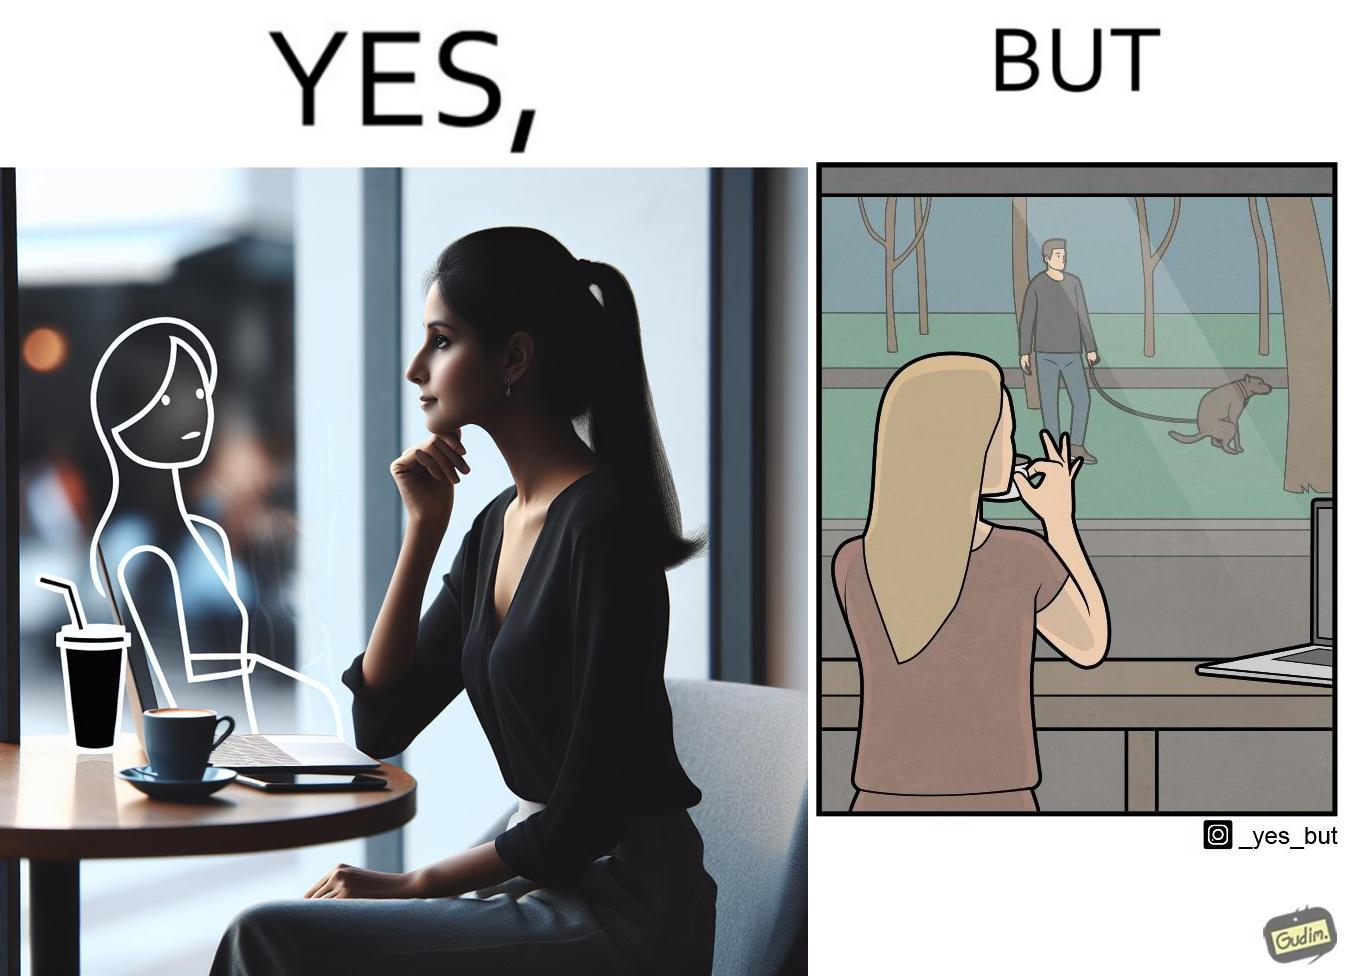What is the satirical meaning behind this image? The image is ironic, because in the first image the woman is seen as enjoying the view but in the second image the same woman is seen as looking at a pooping dog 